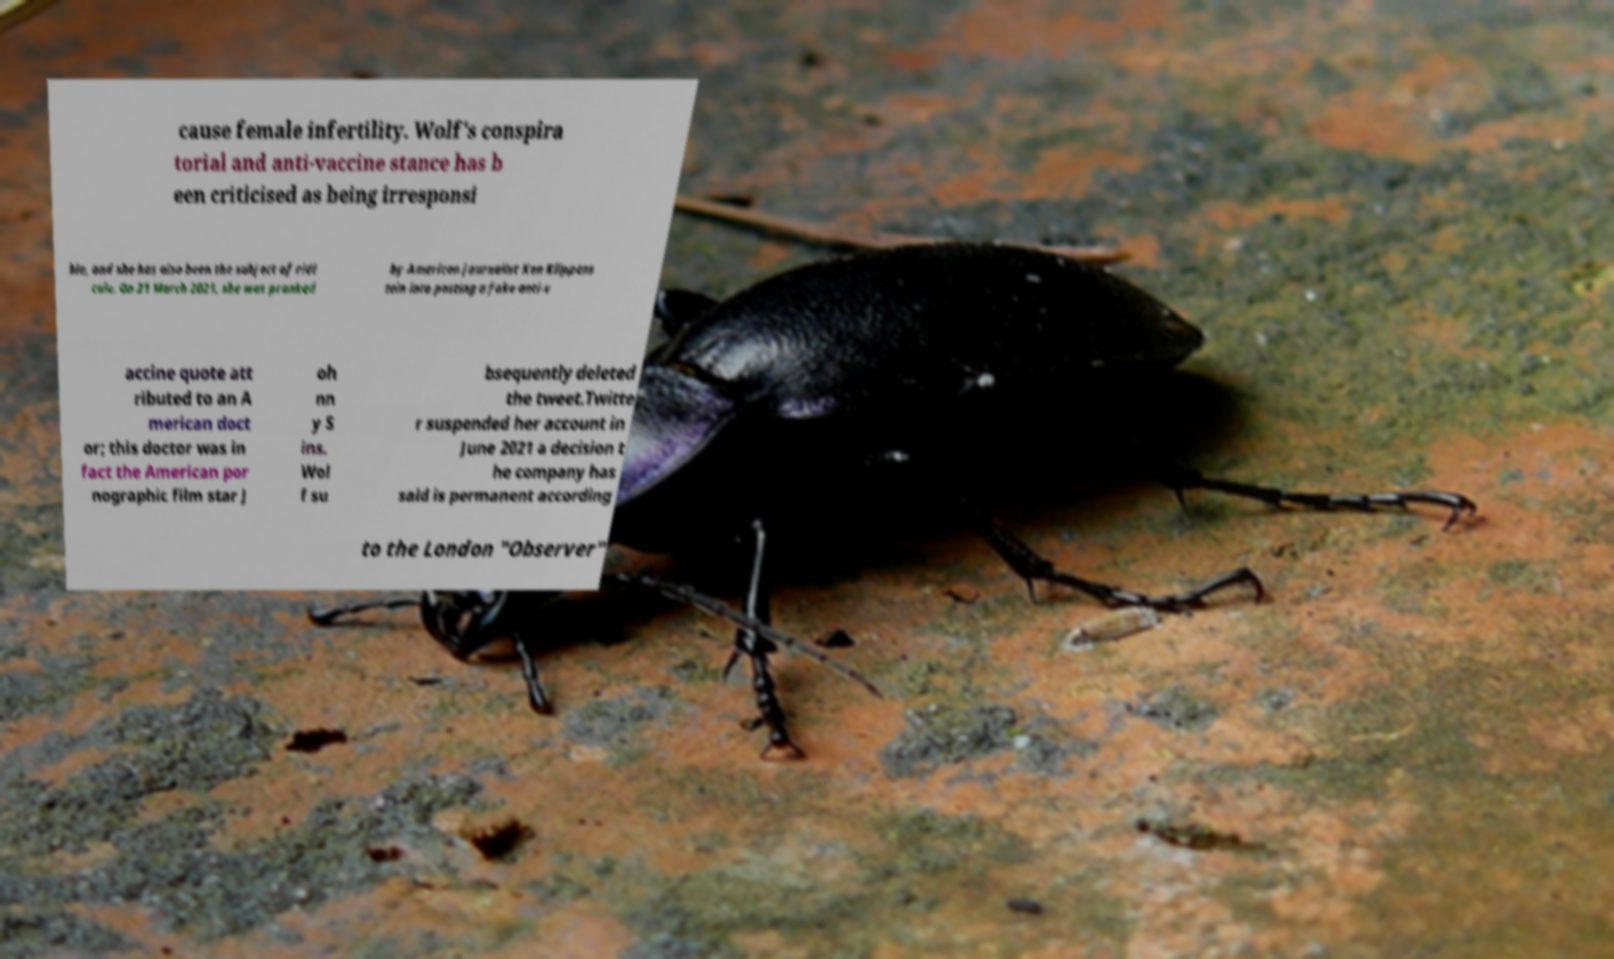There's text embedded in this image that I need extracted. Can you transcribe it verbatim? cause female infertility. Wolf's conspira torial and anti-vaccine stance has b een criticised as being irresponsi ble, and she has also been the subject of ridi cule. On 21 March 2021, she was pranked by American journalist Ken Klippens tein into posting a fake anti-v accine quote att ributed to an A merican doct or; this doctor was in fact the American por nographic film star J oh nn y S ins. Wol f su bsequently deleted the tweet.Twitte r suspended her account in June 2021 a decision t he company has said is permanent according to the London "Observer" 